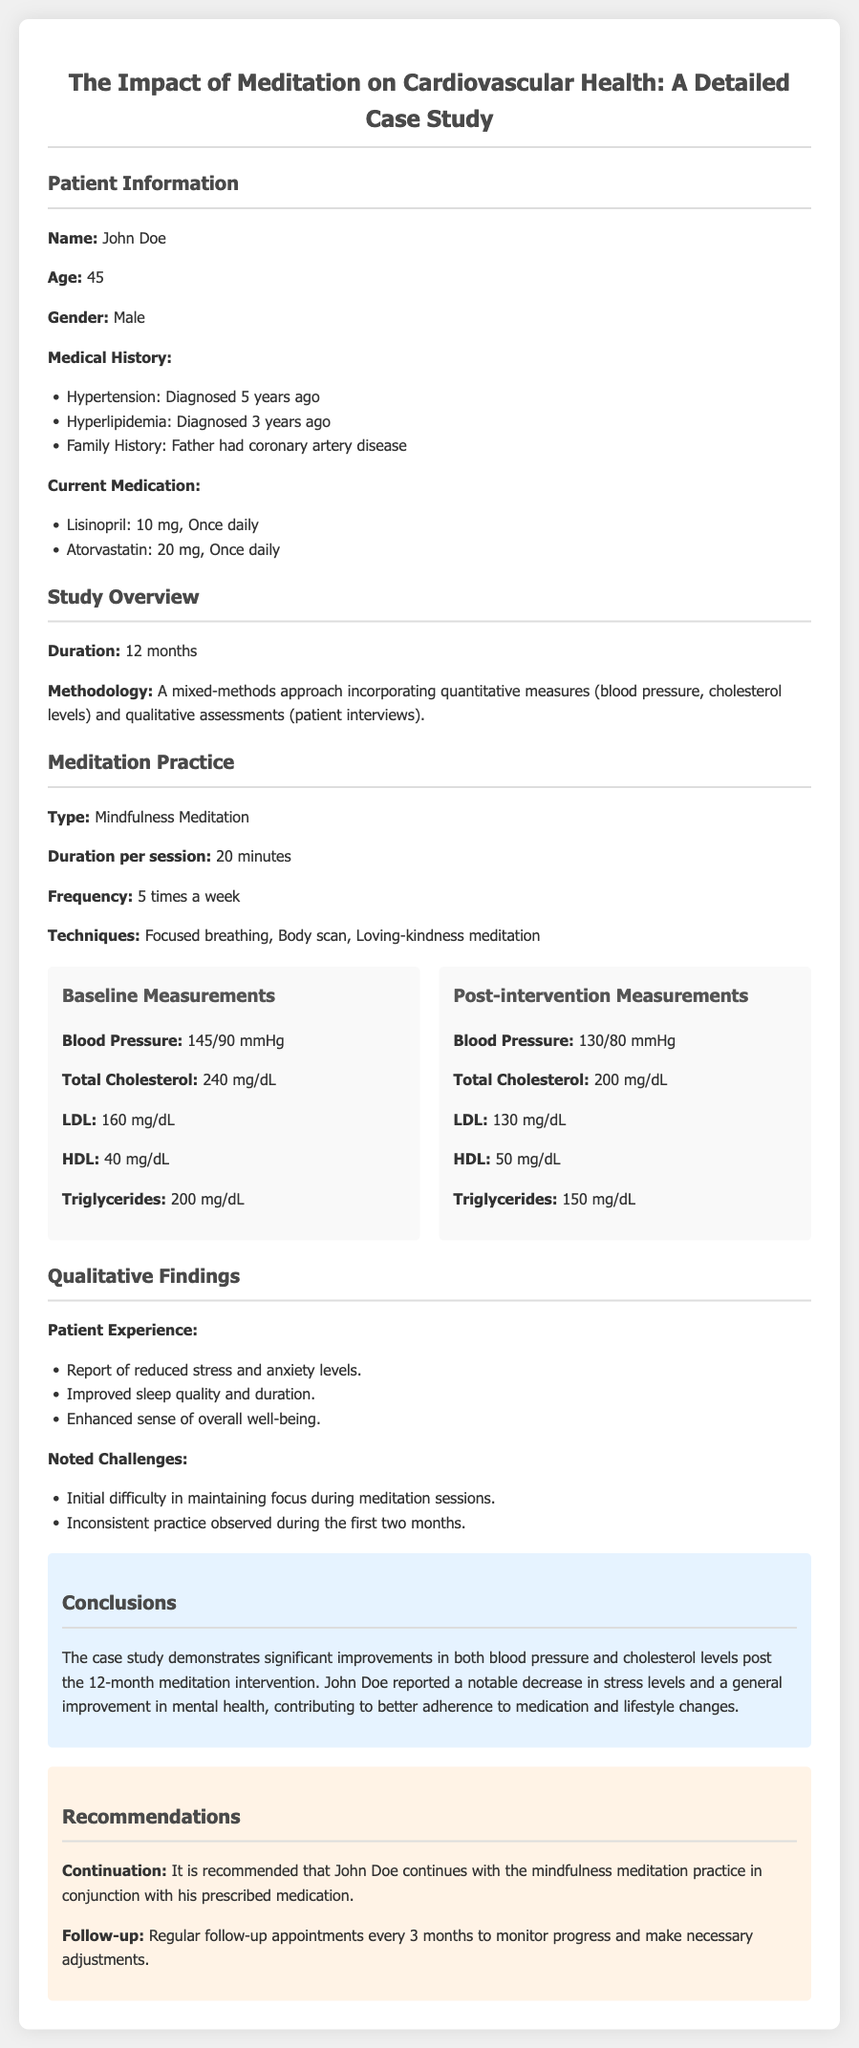What is the name of the patient? The patient's name is listed in the document under Patient Information.
Answer: John Doe How long did the study last? The duration of the study is explicitly mentioned in the Study Overview section.
Answer: 12 months What was the patient's baseline blood pressure? The baseline blood pressure is found in the Baseline Measurements section of the document.
Answer: 145/90 mmHg What type of meditation did the patient practice? The type of meditation practiced is specified in the Meditation Practice section.
Answer: Mindfulness Meditation What improvements were noted in LDL levels after the intervention? The change in LDL levels is detailed in the Post-intervention Measurements, compared to Baseline Measurements.
Answer: Decreased from 160 mg/dL to 130 mg/dL What technique was NOT mentioned among the patient’s meditation practices? The techniques used in meditation are listed in the Meditation Practice section, leading to deducing techniques not mentioned.
Answer: Zen meditation What is recommended for follow-up appointments? The document suggests the frequency of follow-up appointments in the Recommendations section.
Answer: Every 3 months What qualitative finding did the patient report regarding stress? Information relating to the patient's reported experience is found in the Qualitative Findings section.
Answer: Reduced stress and anxiety levels What medication is the patient taking for hypertension? The current medication for hypertension is listed in the Current Medication section.
Answer: Lisinopril 